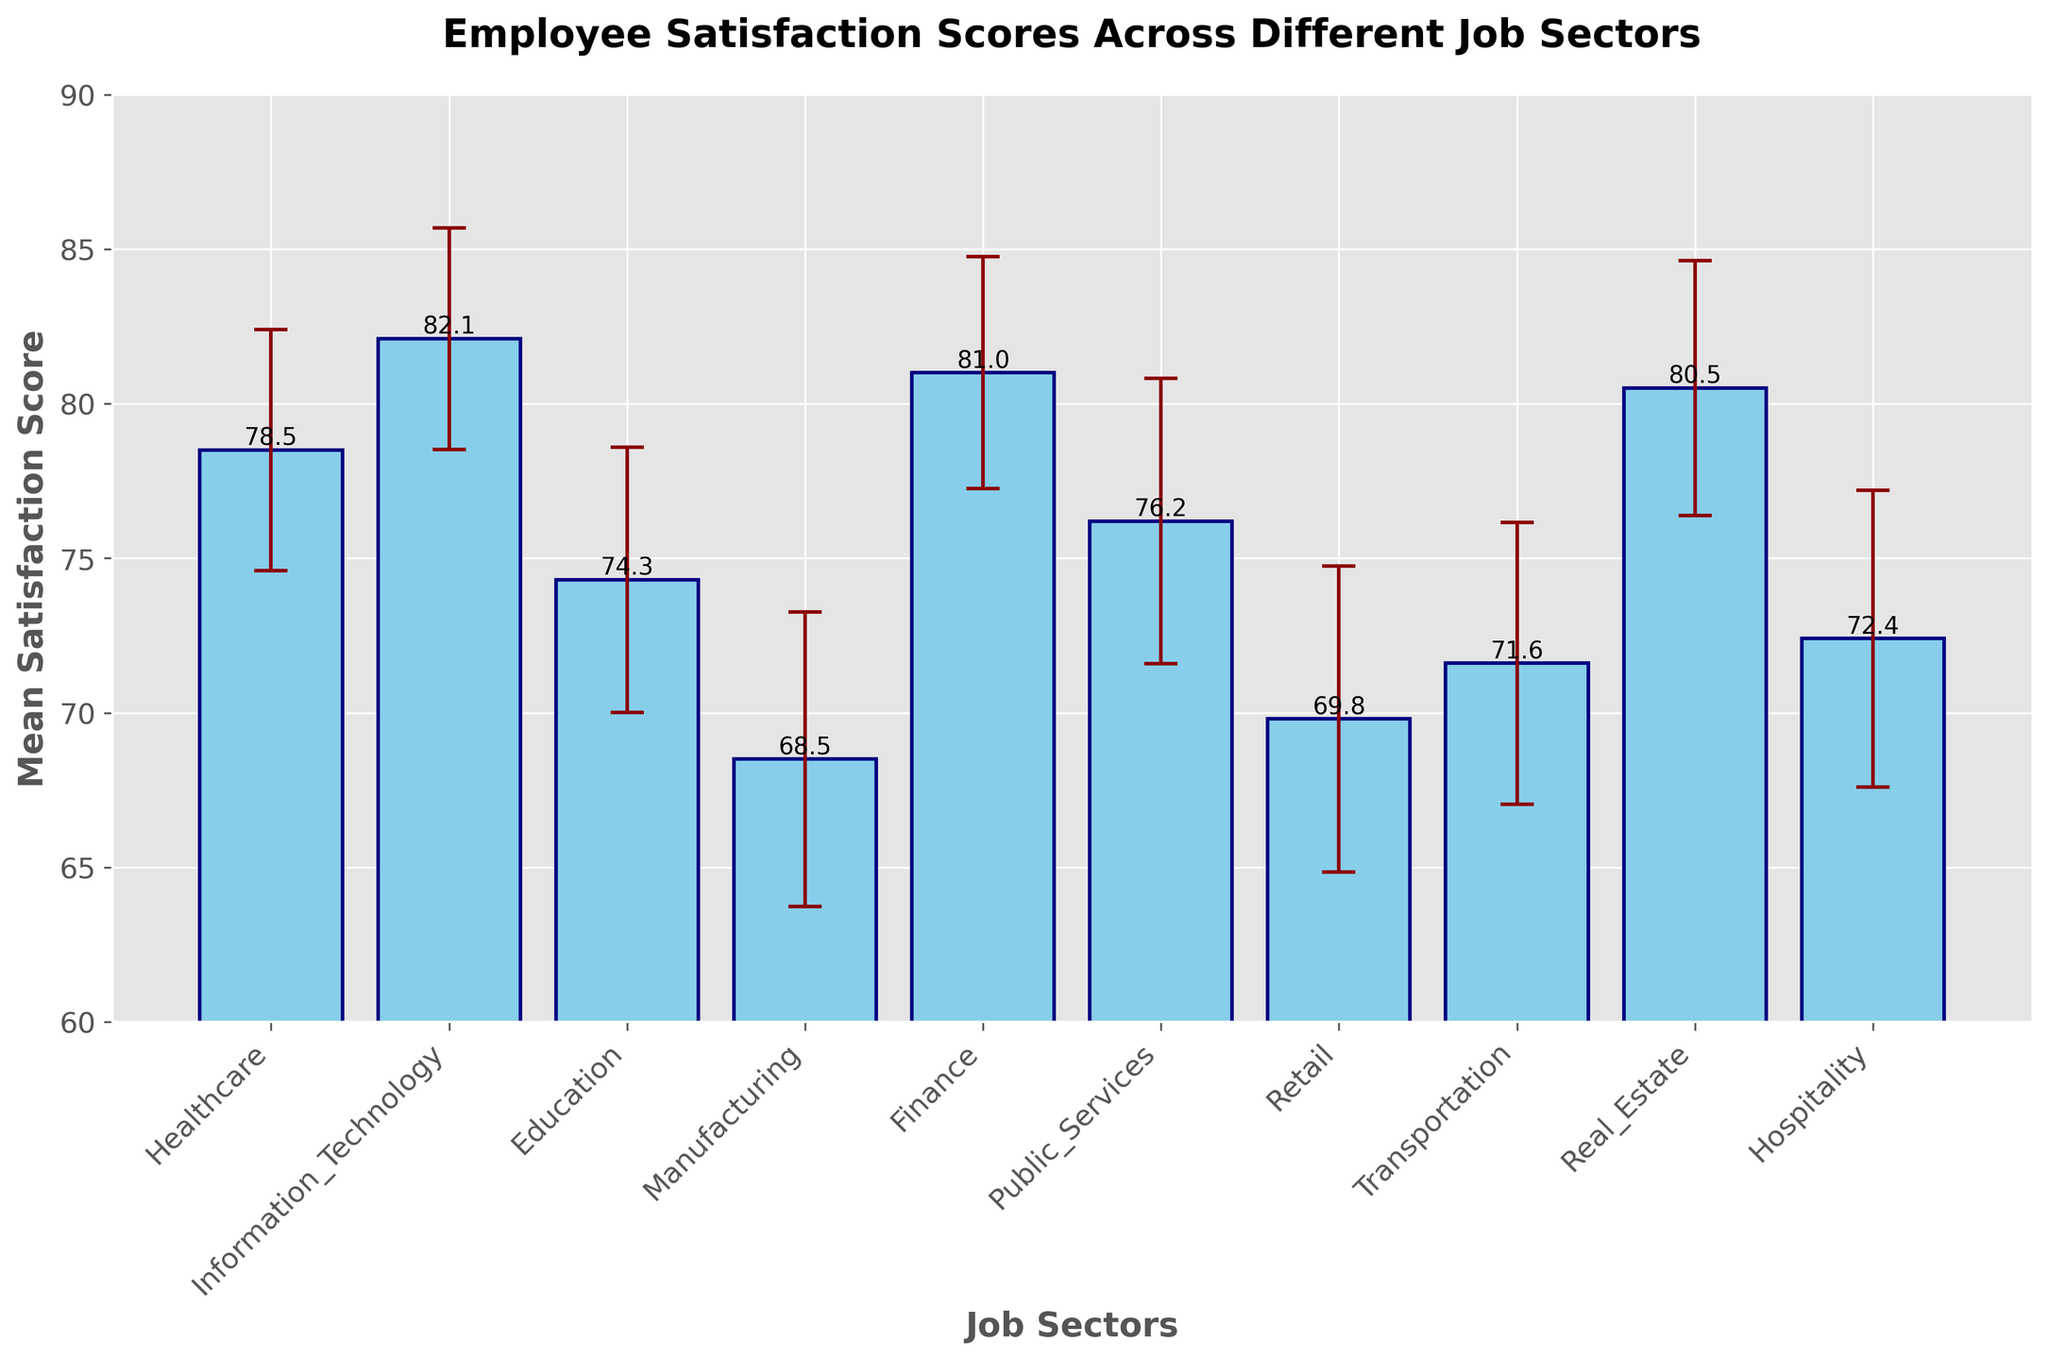What is the title of the bar chart? The title of the bar chart is displayed at the top center of the figure. It indicates the overall topic of the chart.
Answer: Employee Satisfaction Scores Across Different Job Sectors What is the average satisfaction score for the Information Technology sector? Locate the bar corresponding to Information Technology and read the value indicated by the top of the bar.
Answer: 82.1 Which job sector has the lowest mean satisfaction score? Identify the shortest bar in the chart, as it represents the lowest mean satisfaction score.
Answer: Manufacturing How does the mean satisfaction score of Finance compare to that of Healthcare? Locate and compare the heights of the bars for Finance and Healthcare; the taller bar indicates a higher satisfaction score.
Answer: Finance has a higher score than Healthcare What is the variance for the Retail sector? Identify the bar for the Retail sector, noting the length of the error bar can give a clue; or refer back to the initial data given.
Answer: 24.5 What is the difference between the mean satisfaction scores of the Real Estate and Education sectors? Subtract the mean satisfaction score of Education (74.3) from that of Real Estate (80.5).
Answer: 6.2 Which job sector has the highest variance in satisfaction score? The job sector with the longest error bar typically has the highest variance.
Answer: Retail What is the range of the mean satisfaction scores in this bar chart? Subtract the lowest mean satisfaction score from the highest mean satisfaction score.
Answer: 82.1 - 68.5 = 13.6 Is the mean satisfaction score of Public Services above or below 75? Locate the bar for Public Services and observe its height in relation to the score of 75, which is marked on the y-axis.
Answer: Above How does the error bar for Hospitality compare to that of Healthcare? Compare the lengths of the error bars for Hospitality and Healthcare. The longer error bar indicates higher variance.
Answer: Hospitality's error bar is longer than Healthcare's 